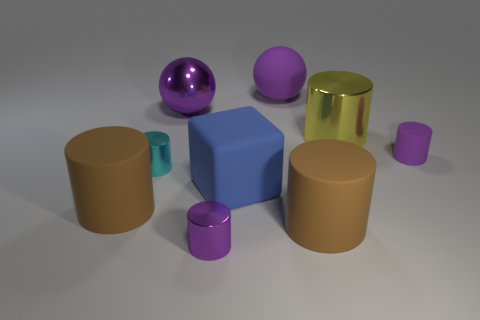The yellow thing is what size?
Offer a terse response. Large. What size is the brown rubber thing right of the small cyan cylinder that is in front of the big shiny object on the left side of the large yellow cylinder?
Your response must be concise. Large. Are there any big blue blocks made of the same material as the cyan cylinder?
Ensure brevity in your answer.  No. The yellow thing has what shape?
Your answer should be compact. Cylinder. What color is the ball that is made of the same material as the blue thing?
Your answer should be compact. Purple. What number of gray things are either tiny cylinders or tiny matte objects?
Your answer should be compact. 0. Are there more tiny purple things than large blue matte blocks?
Offer a very short reply. Yes. How many things are either big matte objects on the left side of the cyan cylinder or tiny matte objects right of the purple metal ball?
Your response must be concise. 2. What is the color of the metallic cylinder that is the same size as the cube?
Provide a short and direct response. Yellow. Does the large blue object have the same material as the large yellow cylinder?
Provide a succinct answer. No. 